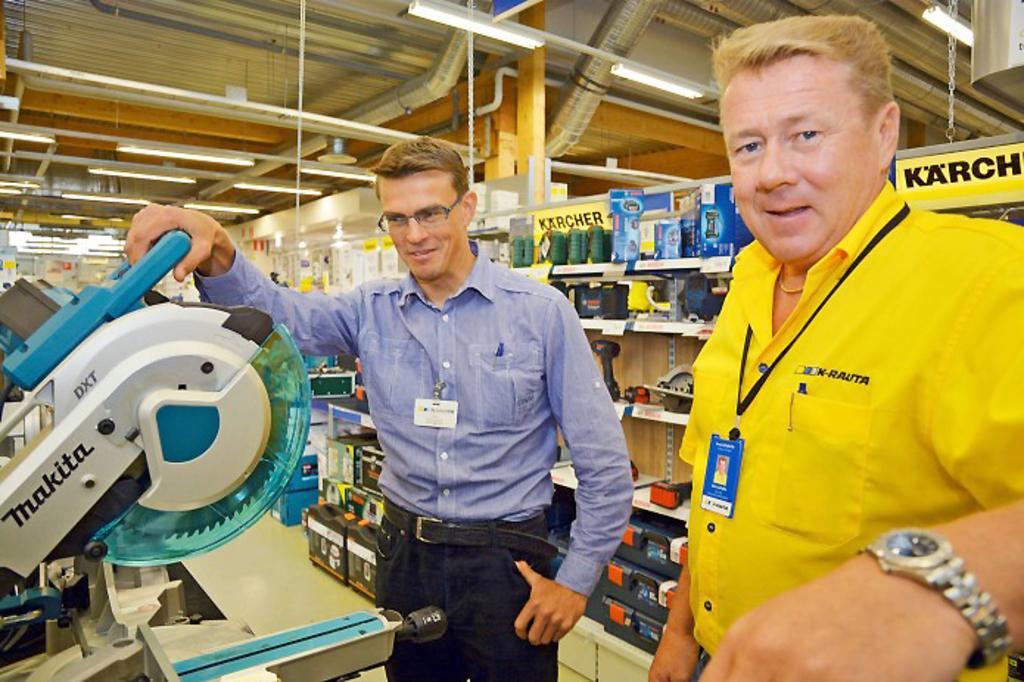Can you describe this image briefly? In this image we can see two persons standing on the floor. In that a man is holding a saw machine. On the backside we can see several items in the racks. We can also see a roof with the ceiling lights. 